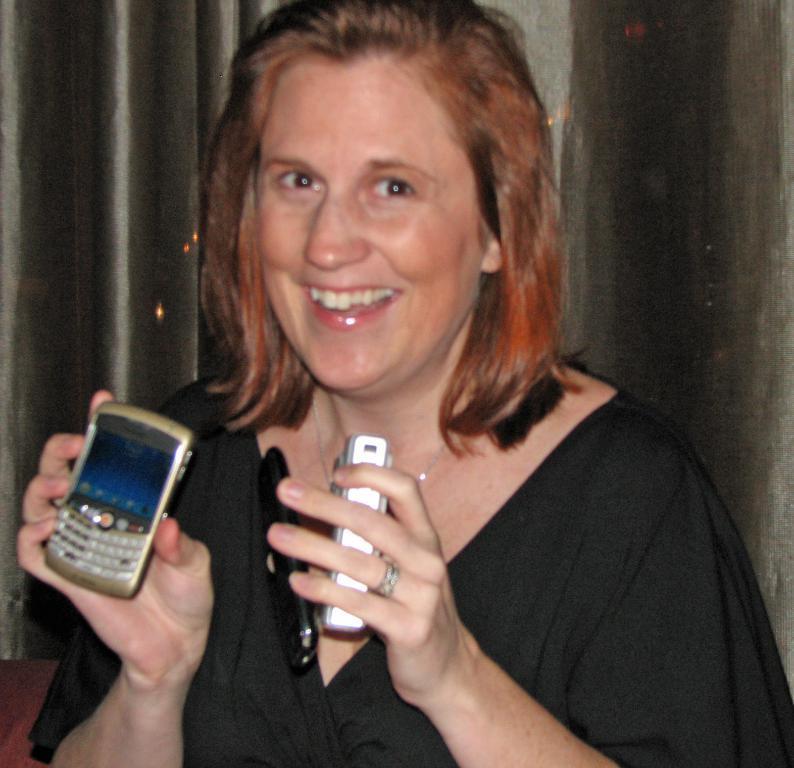Can you describe this image briefly? In this picture there is a women wearing a black top, Standing in the front, smiling and showing the mobile phone. Behind there is a black curtain. 